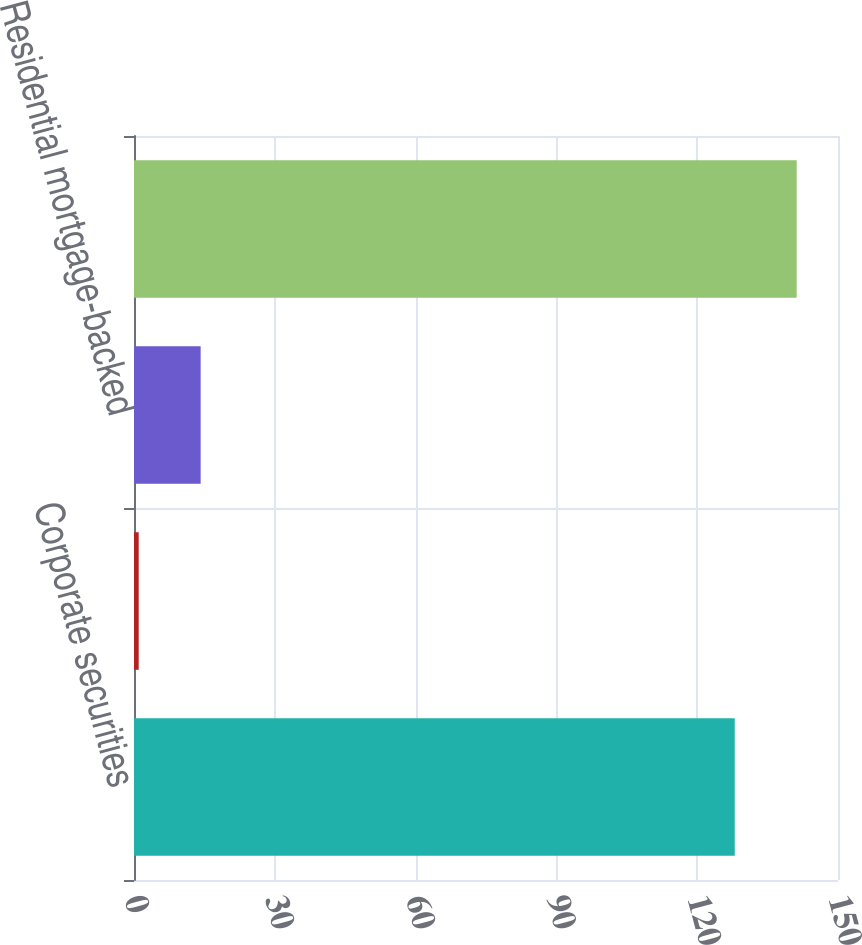<chart> <loc_0><loc_0><loc_500><loc_500><bar_chart><fcel>Corporate securities<fcel>Asset-backed securities<fcel>Residential mortgage-backed<fcel>Total fixed maturities held to<nl><fcel>128<fcel>1<fcel>14.2<fcel>141.2<nl></chart> 